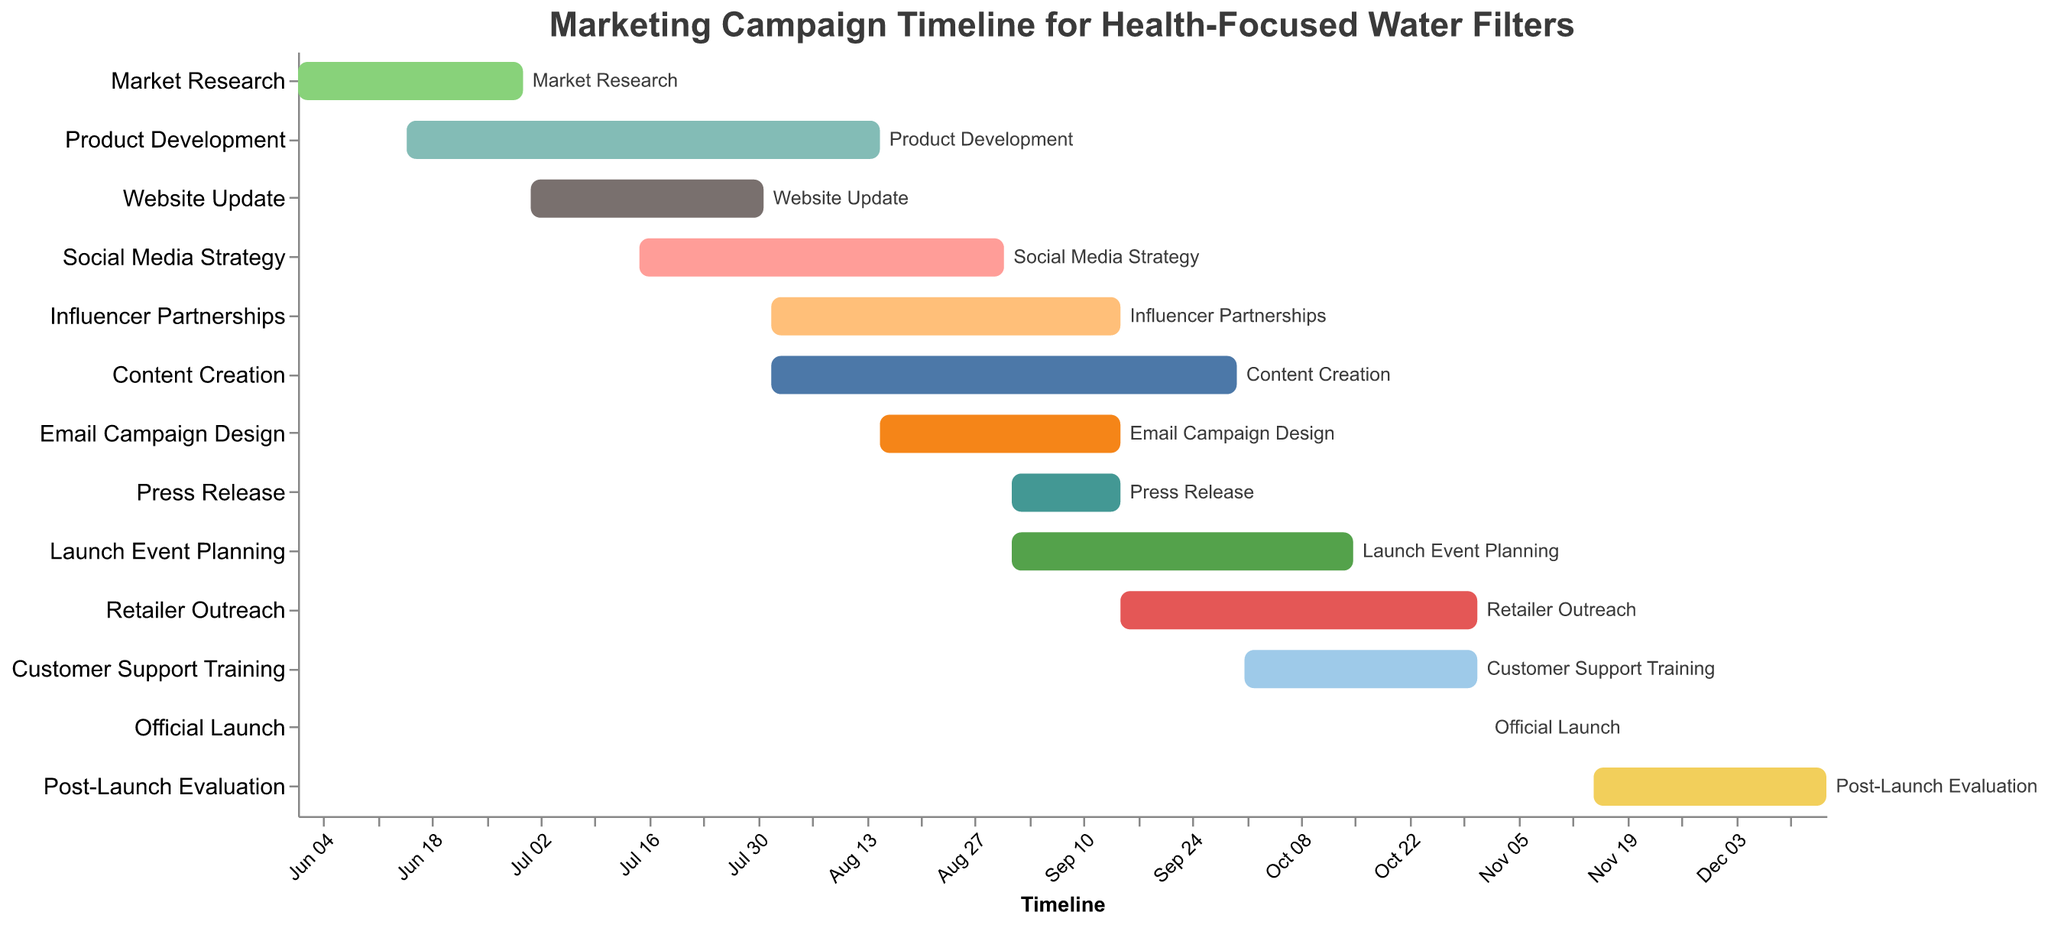Which task starts first? The figure's timeline on the x-axis represents the start dates of each task. The first bar on the timeline starts at the earliest date. "Market Research" starts on 2023-06-01, which is the earliest date.
Answer: Market Research Which task ends last? Look at the end points of all the bars on the timeline. The last bar that extends to the farthest date represents the task that ends last. "Post-Launch Evaluation" ends on 2023-12-15, which is the latest date.
Answer: Post-Launch Evaluation How many tasks are there in total? Count the number of unique tasks listed on the y-axis. There are 13 different tasks.
Answer: 13 What is the duration of the "Product Development" task? Find the start and end dates for "Product Development" on the figure, which are 2023-06-15 and 2023-08-15 respectively. Calculate the difference between these dates.
Answer: 2 months Which tasks overlap with "Social Media Strategy"? Identify the time range for "Social Media Strategy" (2023-07-15 to 2023-08-31) and see which other bars overlap with this date range. The tasks overlapping are "Product Development," "Website Update," "Influencer Partnerships," "Content Creation," and "Email Campaign Design."
Answer: Product Development, Website Update, Influencer Partnerships, Content Creation, Email Campaign Design What is the shortest task in the timeline? Compare the lengths of each bar on the Gantt chart. The shortest bar represents the shortest task. "Official Launch" spans only one day, making it the shortest task.
Answer: Official Launch Which tasks begin in September 2023? Observe the timeline to see which tasks have their start dates in September 2023. The tasks that begin in September 2023 are "Press Release," "Launch Event Planning," and "Retailer Outreach."
Answer: Press Release, Launch Event Planning, Retailer Outreach Are there any tasks that start and end in the same month? Look for tasks whose start and end dates fall within the same month on the timeline. "Market Research," "Website Update," "Press Release," and "Official Launch" start and end in the same month.
Answer: Market Research, Website Update, Press Release, Official Launch What is the total duration of all tasks combined? Find the duration for each task by calculating the difference between their start and end dates, then sum these durations. This involves adding up all the individual durations from the tasks.
Answer: 315 days 